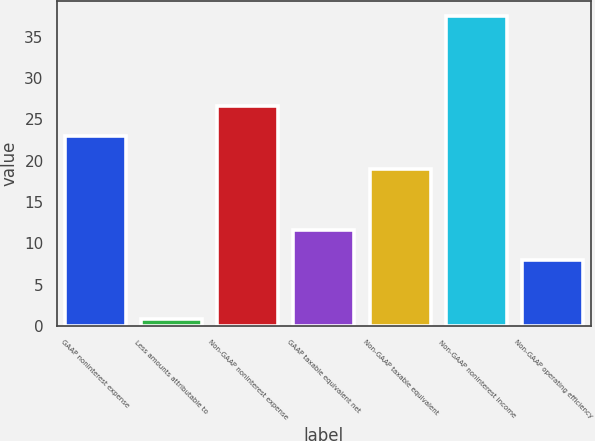<chart> <loc_0><loc_0><loc_500><loc_500><bar_chart><fcel>GAAP noninterest expense<fcel>Less amounts attributable to<fcel>Non-GAAP noninterest expense<fcel>GAAP taxable equivalent net<fcel>Non-GAAP taxable equivalent<fcel>Non-GAAP noninterest income<fcel>Non-GAAP operating efficiency<nl><fcel>23<fcel>0.8<fcel>26.67<fcel>11.67<fcel>19.01<fcel>37.5<fcel>8<nl></chart> 